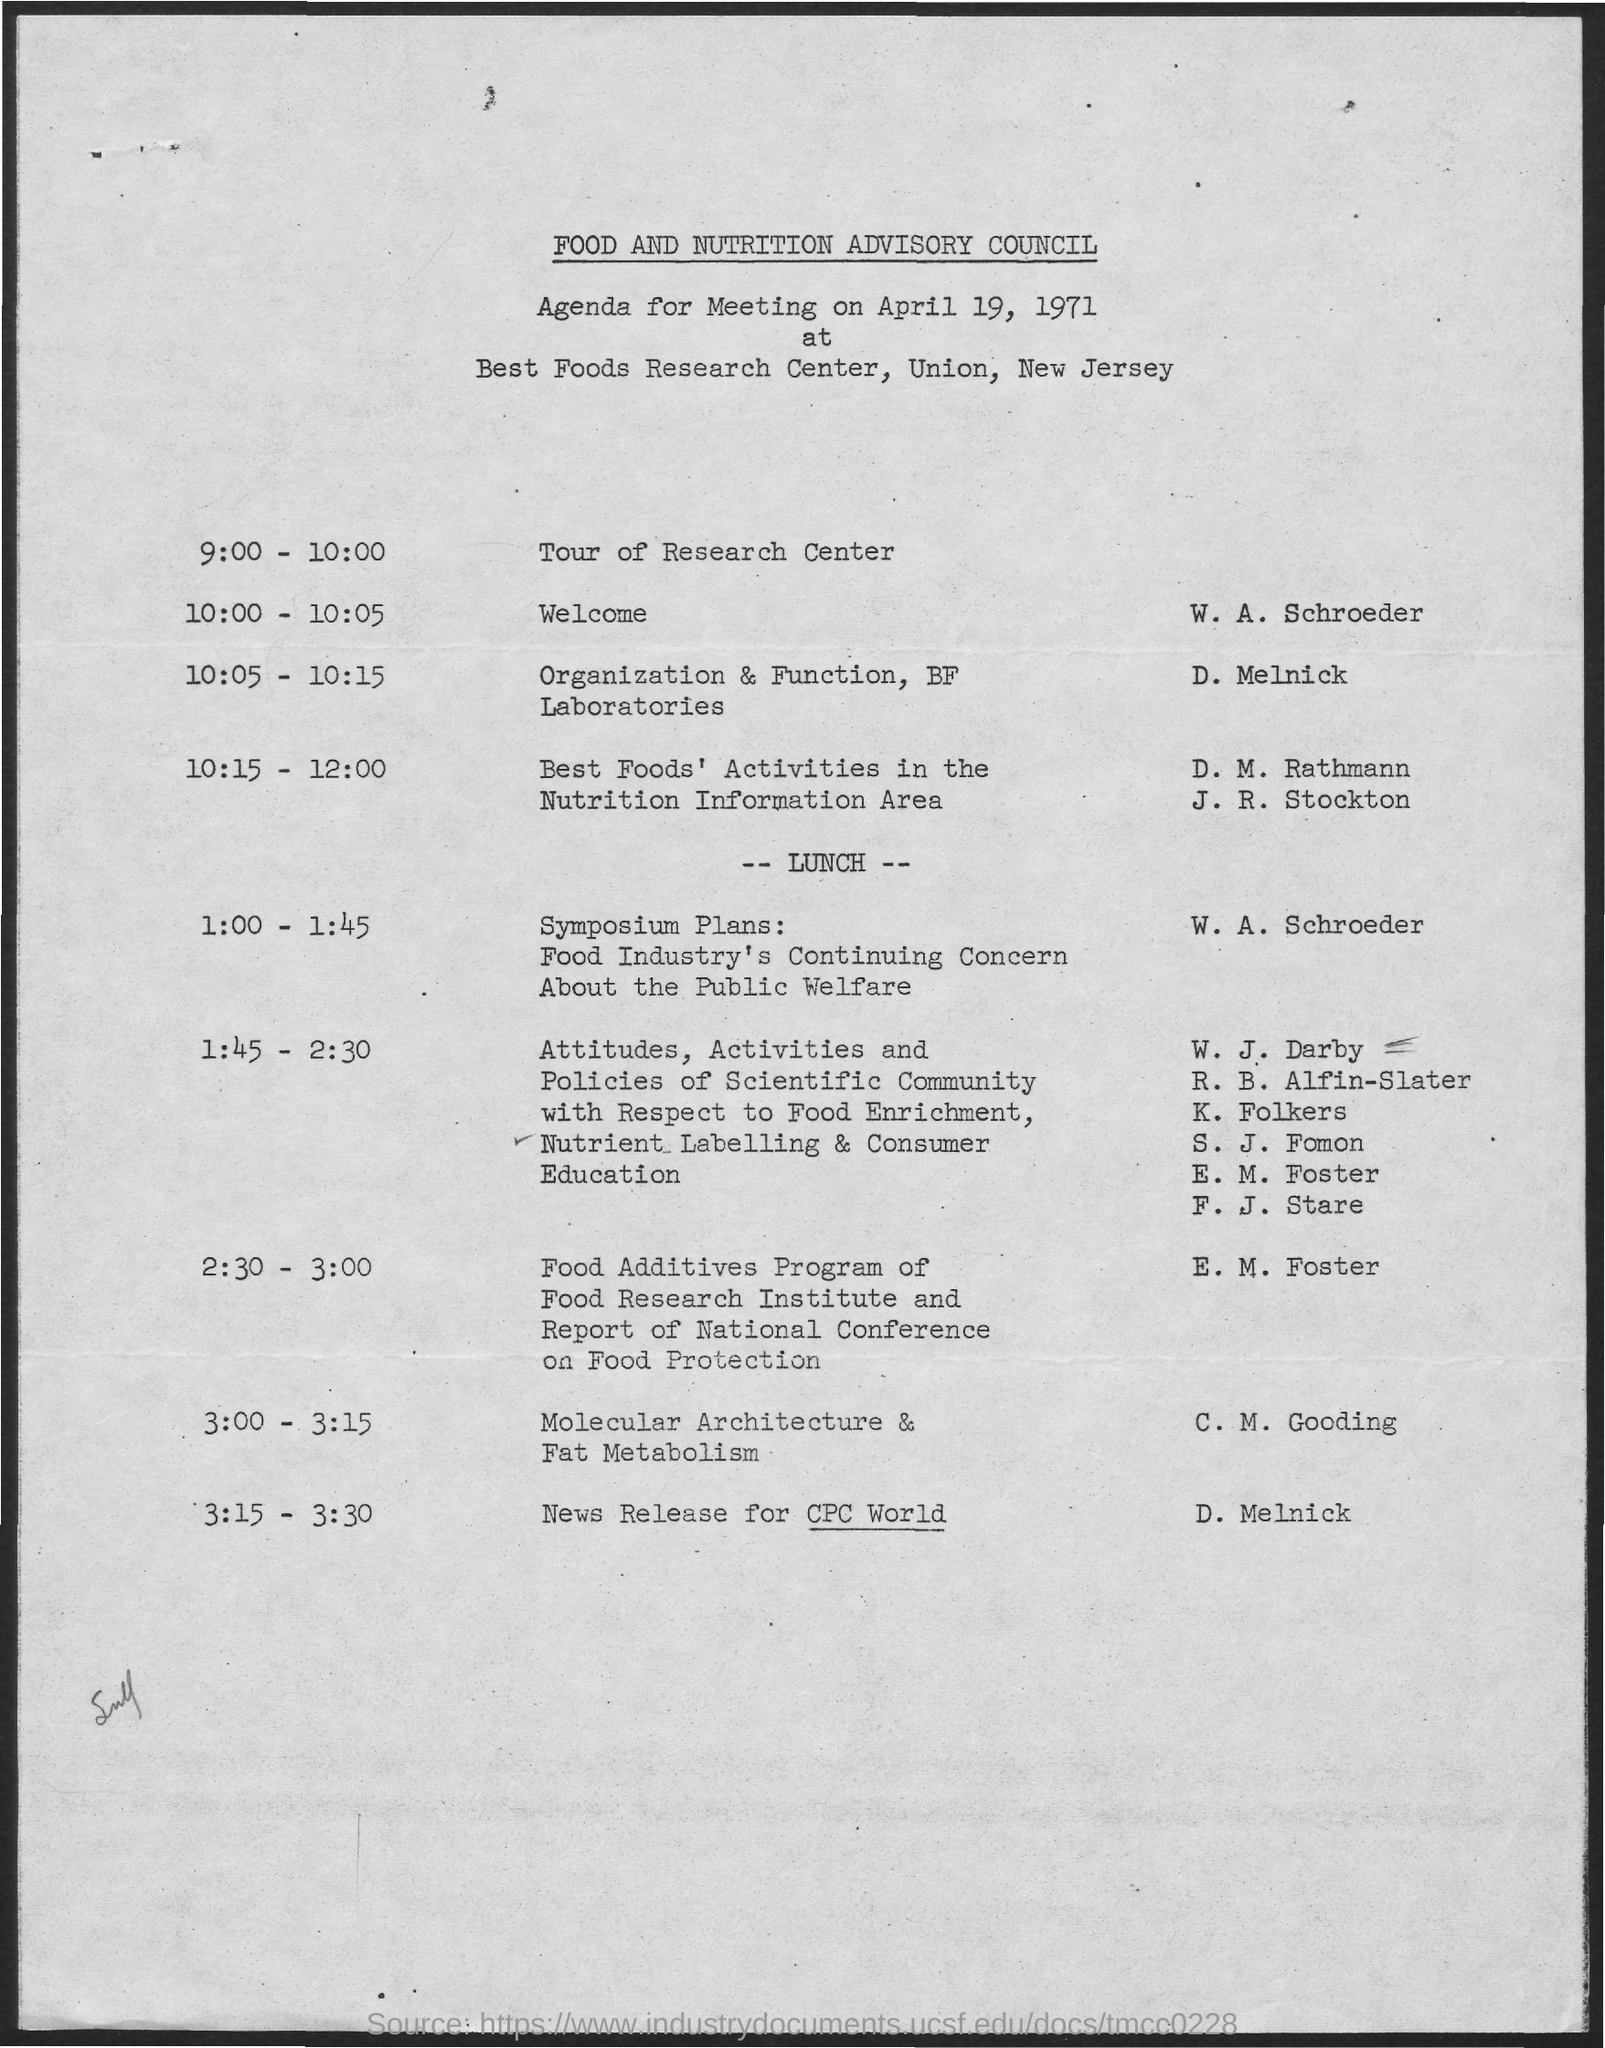Which place is the meeting held?
Keep it short and to the point. Best Foods Research Center. When is the Tour of research center?
Your response must be concise. 9:00 - 10:00. Who is presenting the "Welcome"?
Your answer should be very brief. W. A. Schroeder. When is the welcome?
Your response must be concise. 10:00 - 10:05. Who is presenting News release for CPC World?
Offer a very short reply. D. Melnick. 